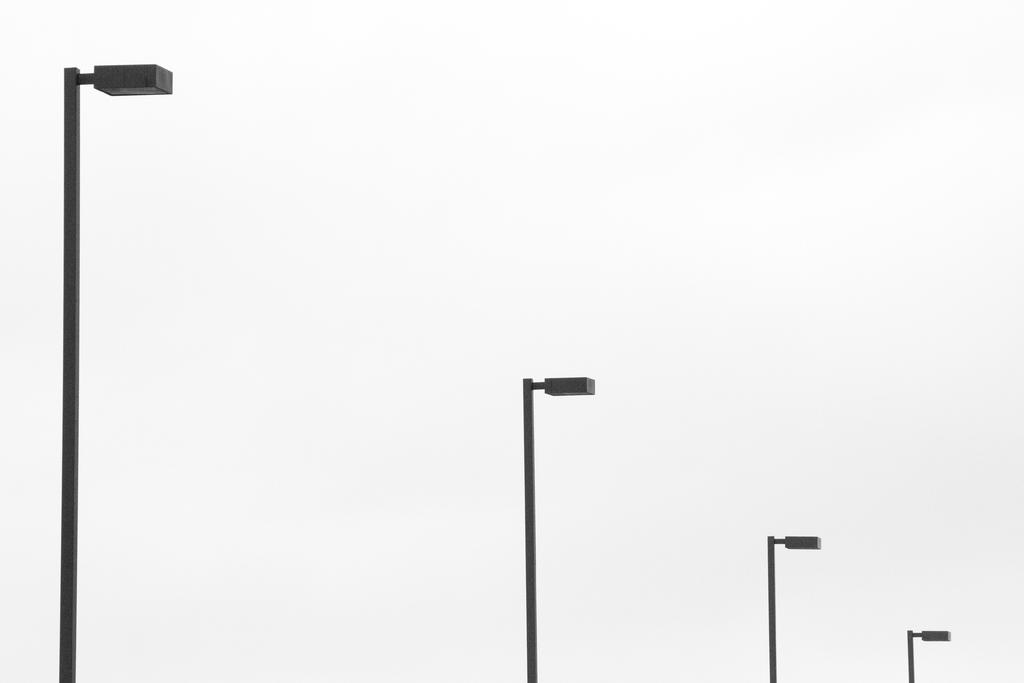What is located in the center of the image? There are light poles in the center of the image. What is the condition of the sky in the image? The sky is cloudy in the image. What type of afterthought can be seen in the image? There is no afterthought present in the image. What kind of brass object is visible in the image? There is no brass object present in the image. 